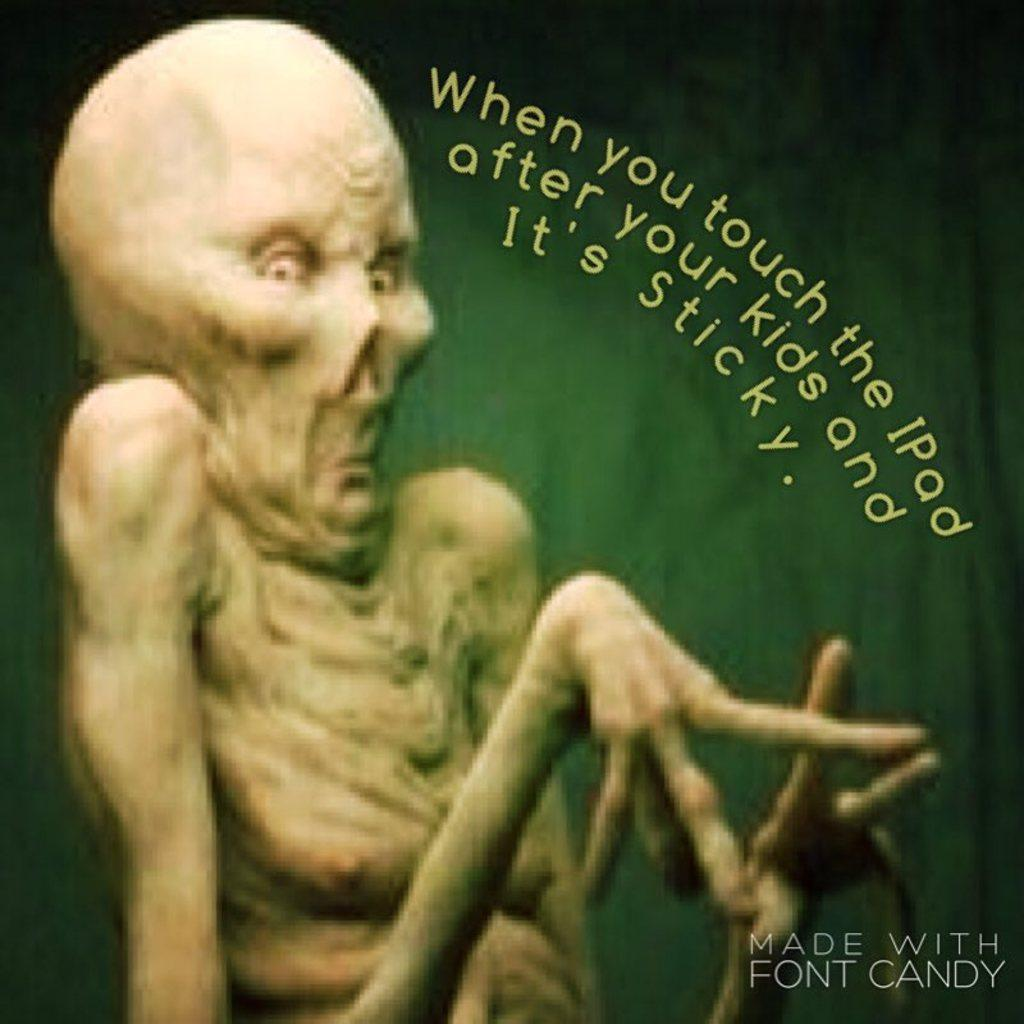What is present on the poster in the image? There is a poster in the image, which contains an image and text. Can you describe the image on the poster? The provided facts do not specify the image on the poster, so we cannot describe it. What information is conveyed through the text on the poster? The provided facts do not specify the text on the poster, so we cannot describe the information conveyed. What type of bubble can be seen floating in the air in the image? There is no bubble present in the image. What type of feast is being depicted in the image? There is no feast depicted in the image; it features a poster with an image and text. 